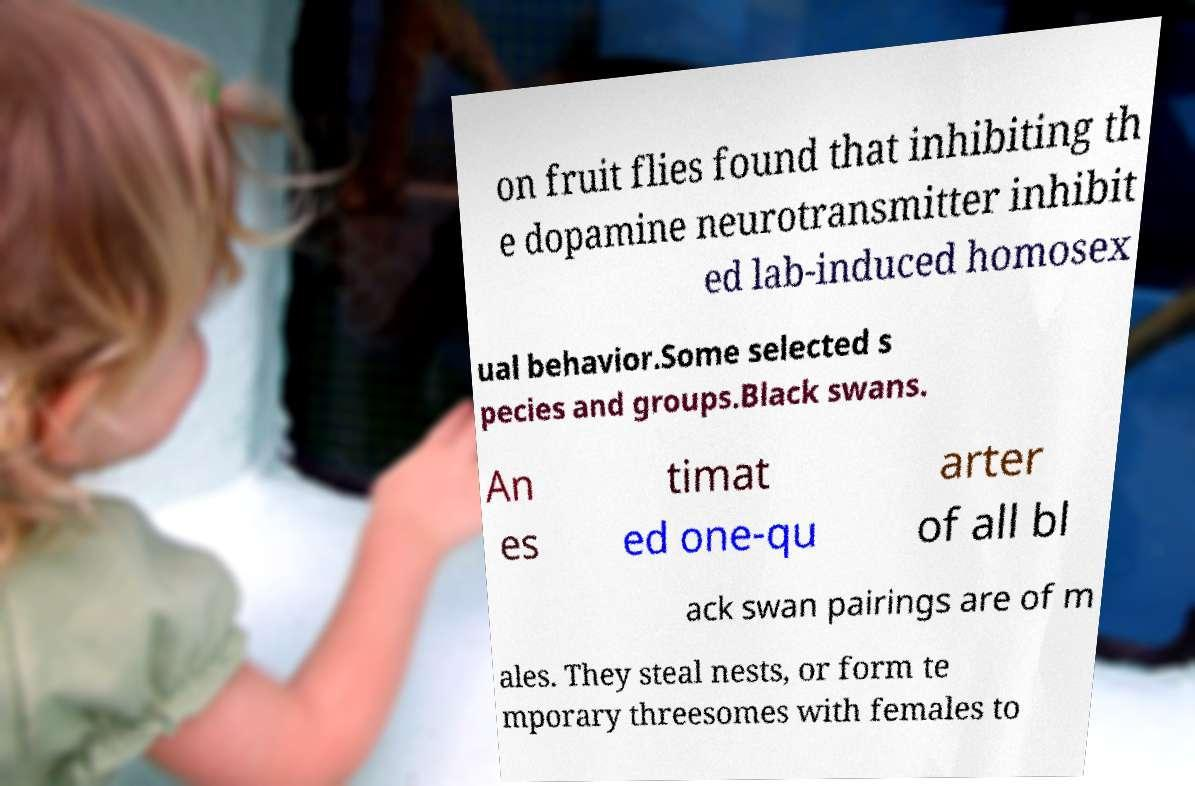Can you accurately transcribe the text from the provided image for me? on fruit flies found that inhibiting th e dopamine neurotransmitter inhibit ed lab-induced homosex ual behavior.Some selected s pecies and groups.Black swans. An es timat ed one-qu arter of all bl ack swan pairings are of m ales. They steal nests, or form te mporary threesomes with females to 